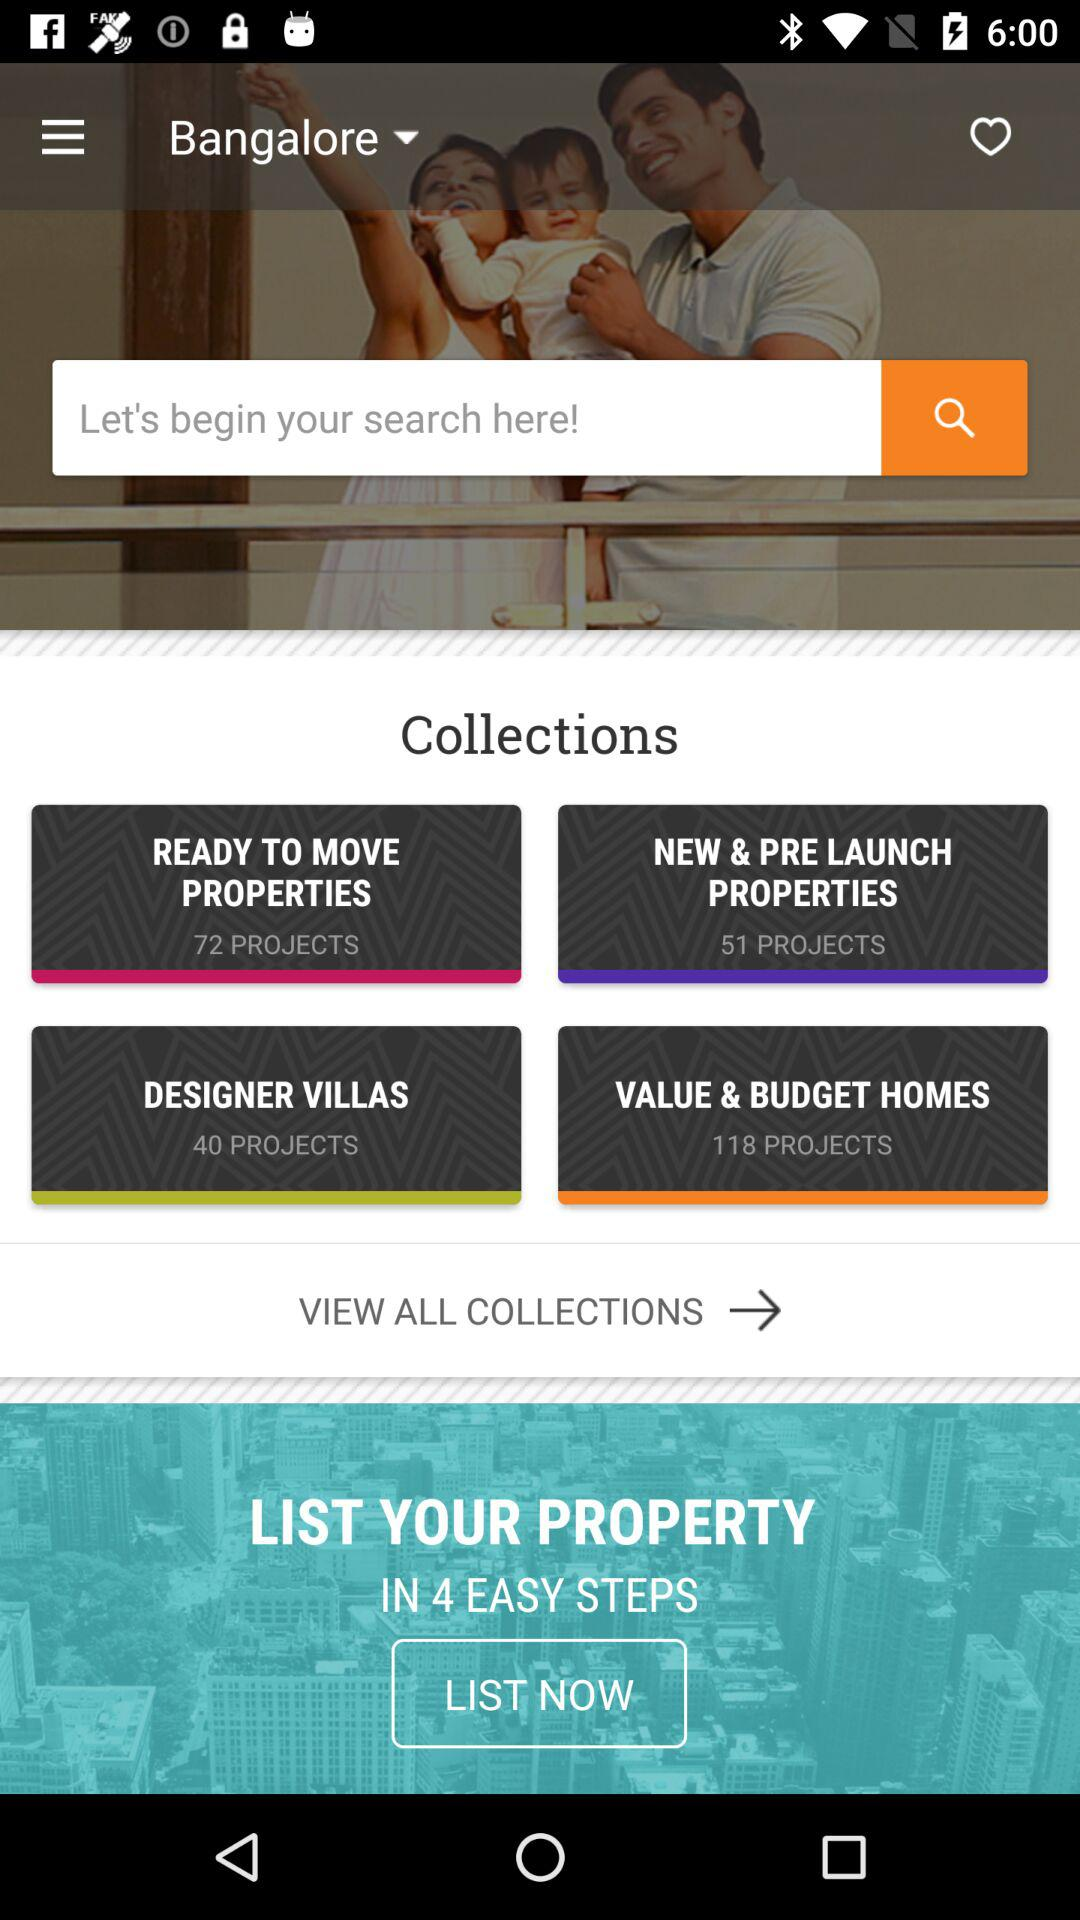How many projects are in the VALUE & BUDGET HOMES collection?
Answer the question using a single word or phrase. 118 